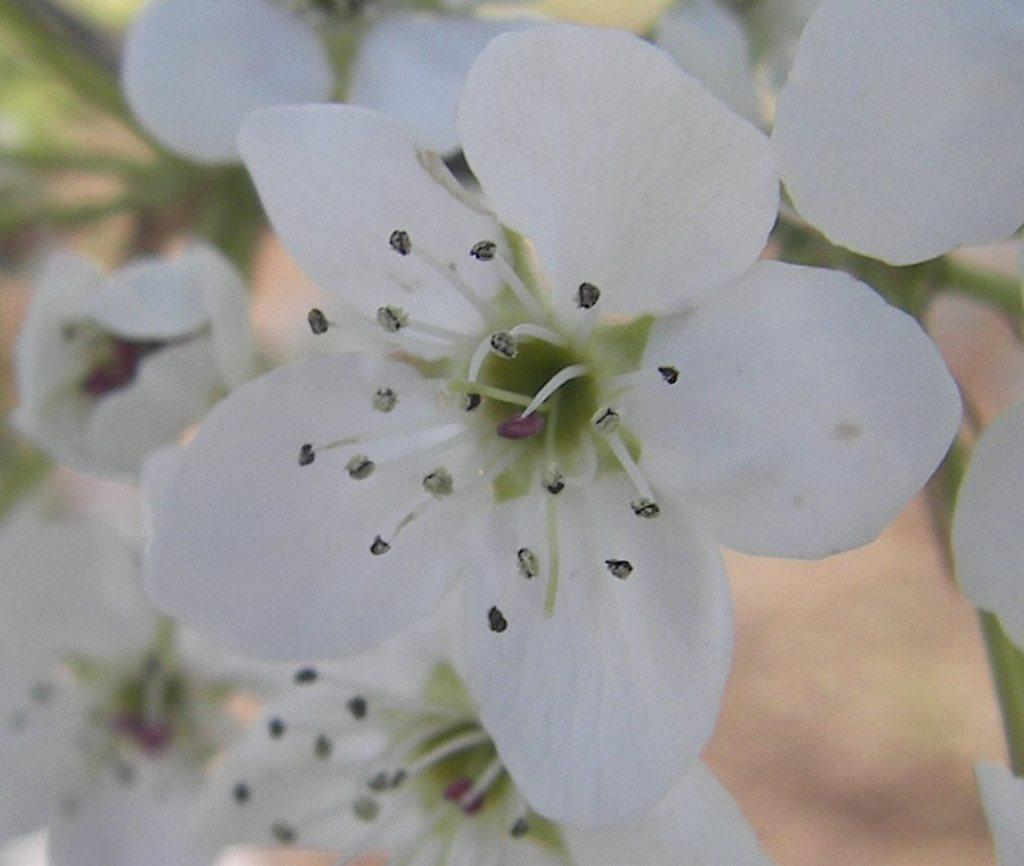What type of flowers can be seen in the image? There are white flowers in the image. What channel is the peace symbol broadcasting on in the image? There is no channel or peace symbol present in the image; it only features white flowers. 